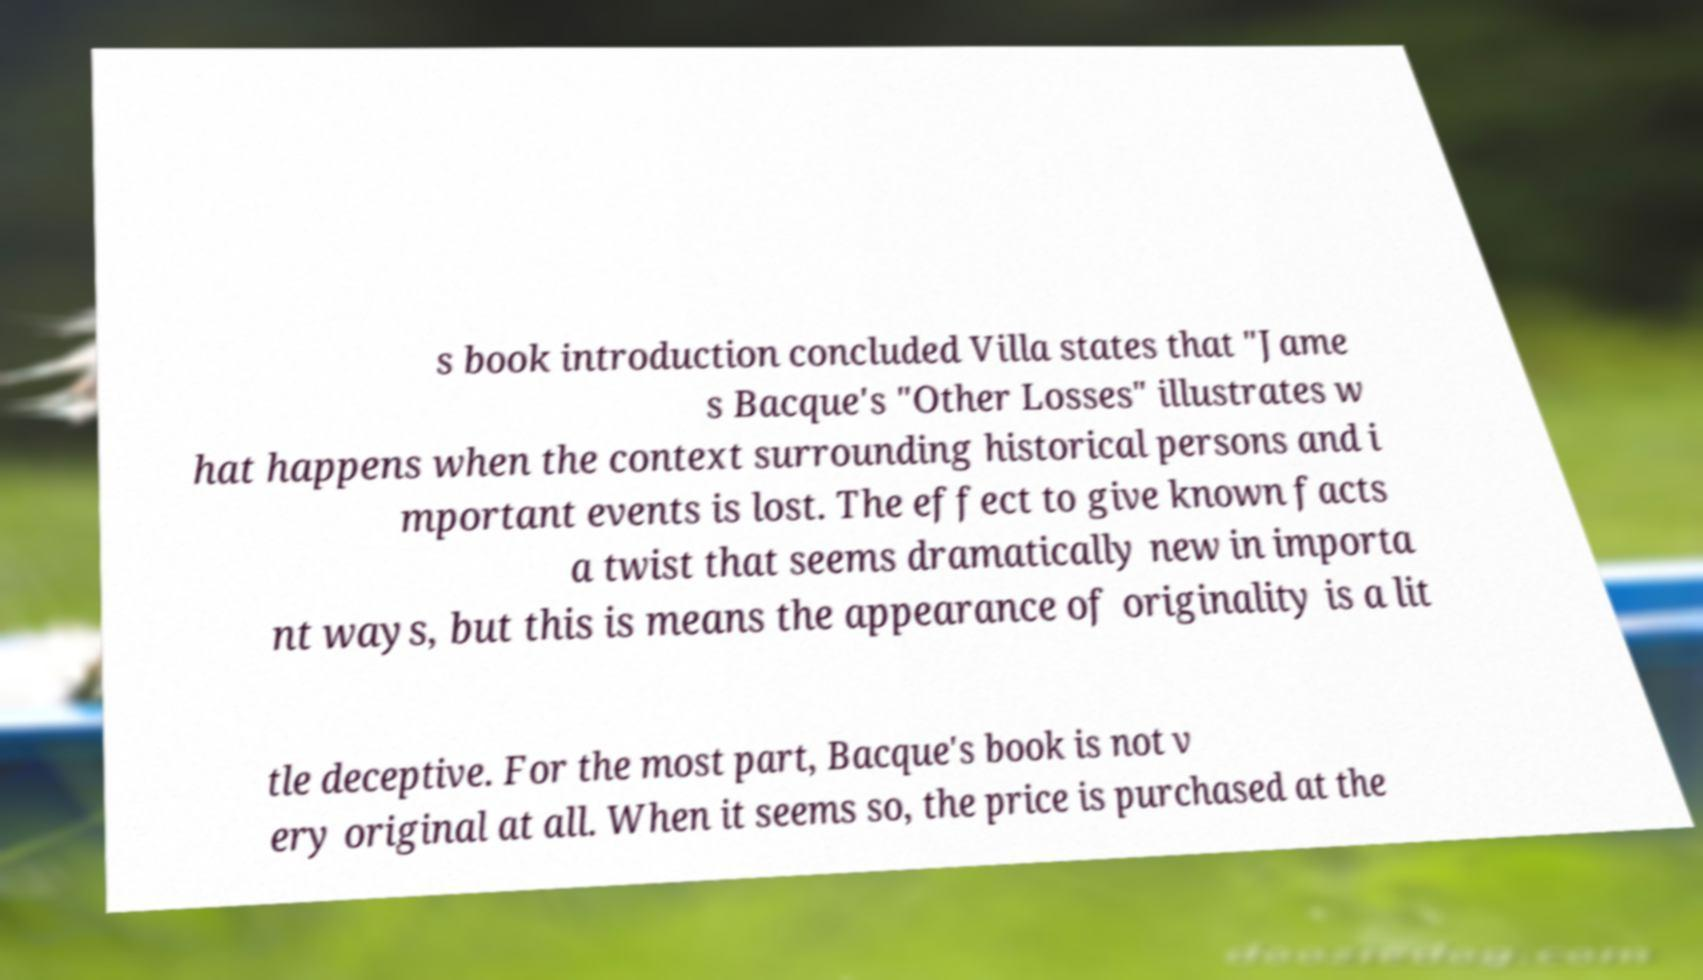I need the written content from this picture converted into text. Can you do that? s book introduction concluded Villa states that "Jame s Bacque's "Other Losses" illustrates w hat happens when the context surrounding historical persons and i mportant events is lost. The effect to give known facts a twist that seems dramatically new in importa nt ways, but this is means the appearance of originality is a lit tle deceptive. For the most part, Bacque's book is not v ery original at all. When it seems so, the price is purchased at the 